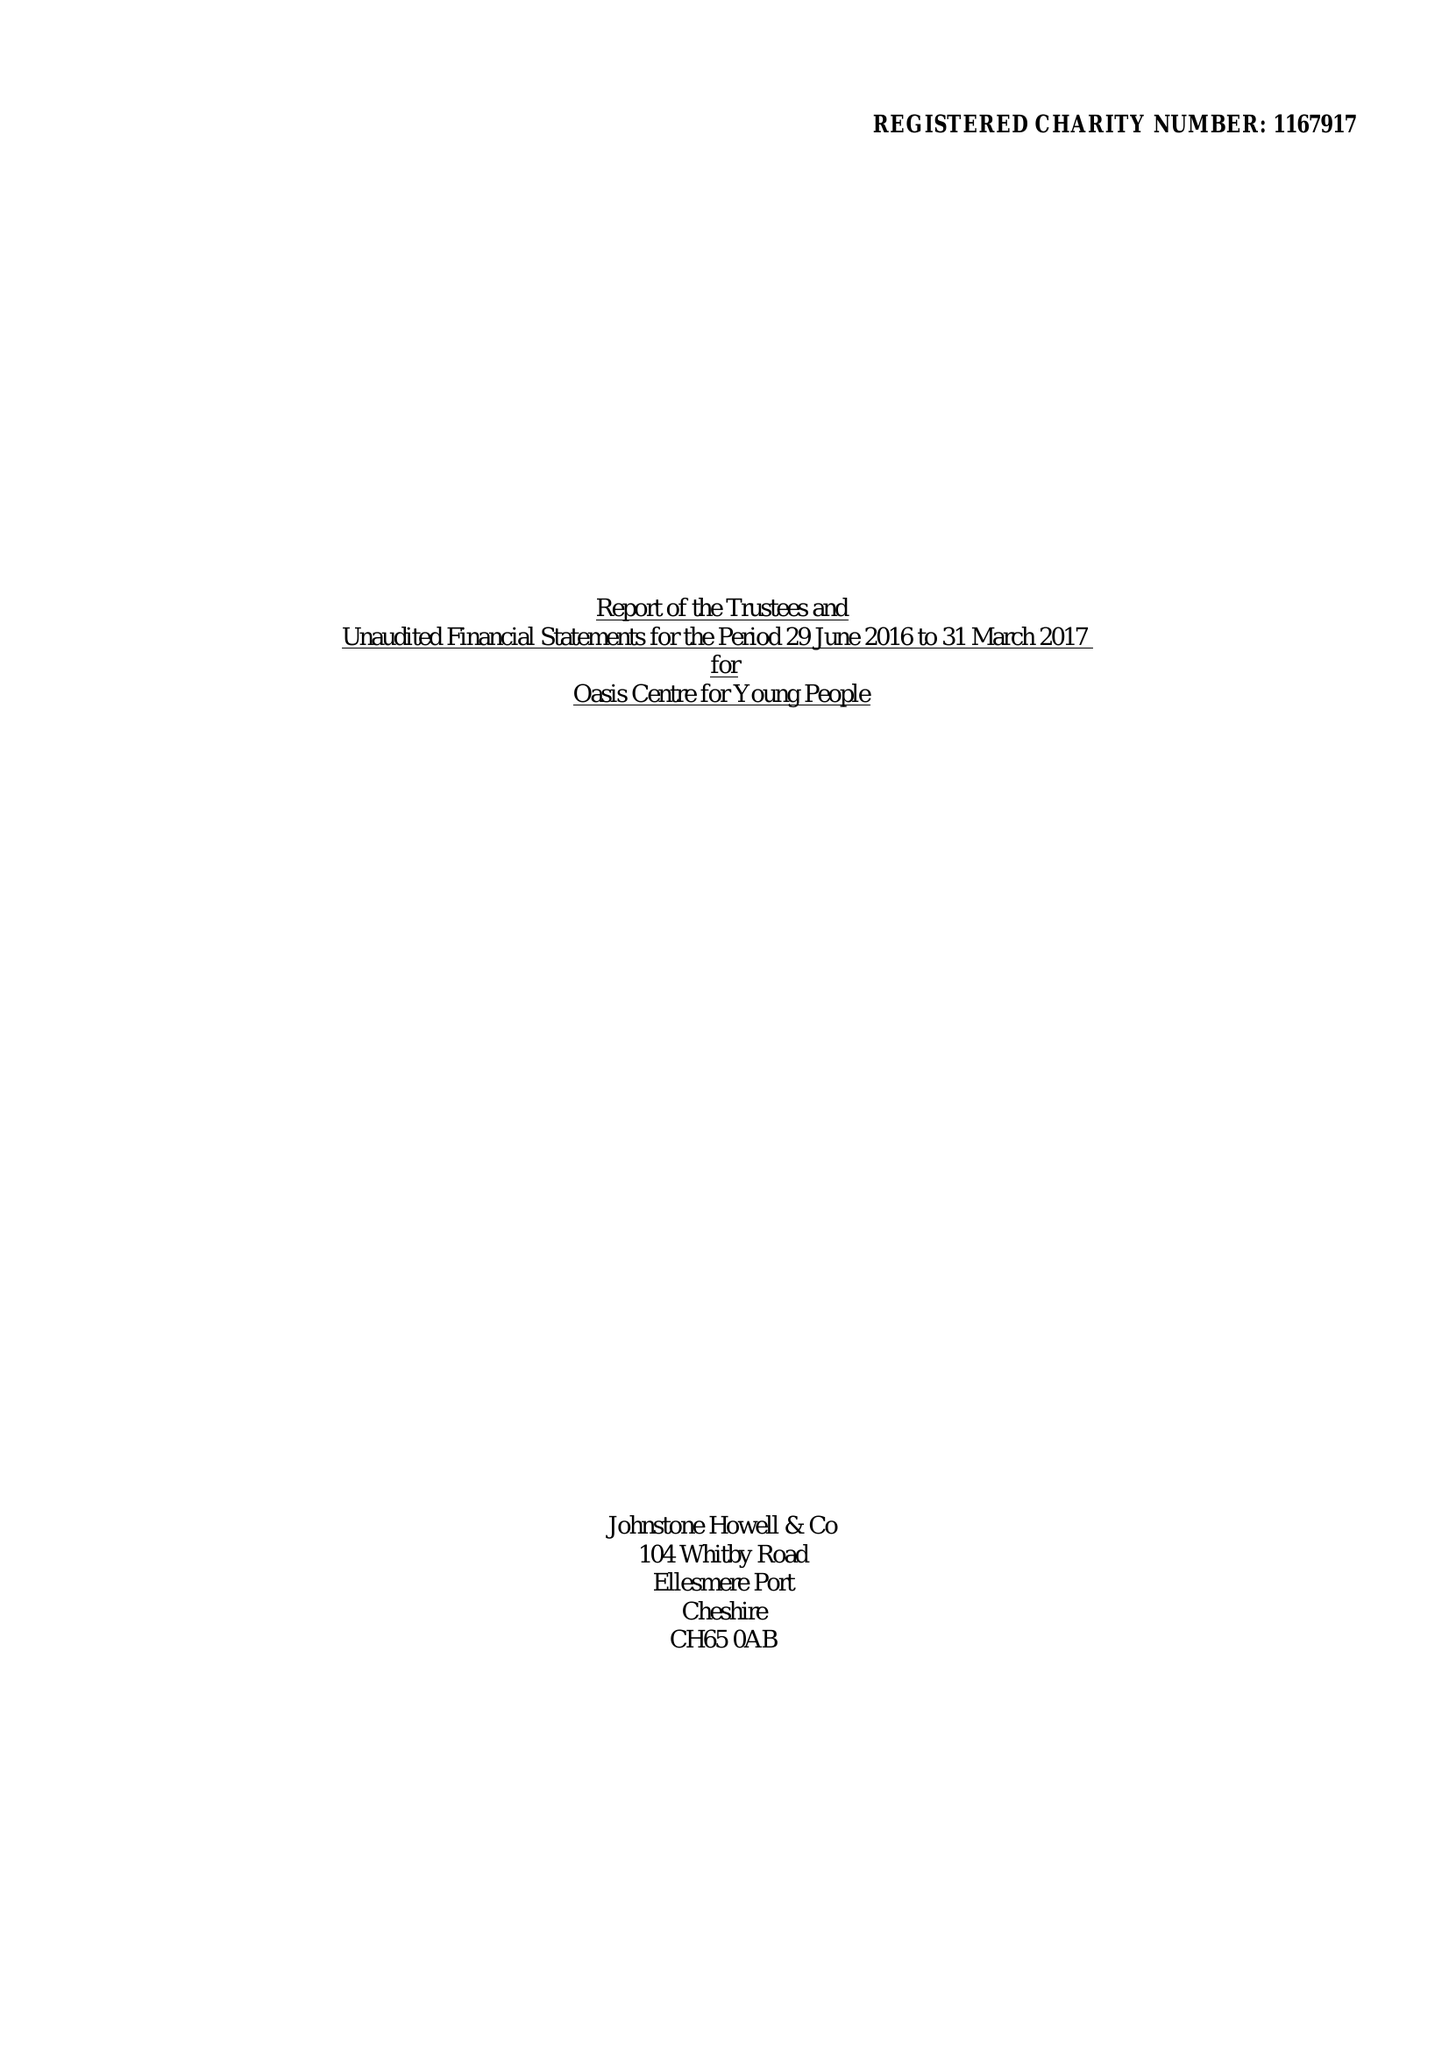What is the value for the income_annually_in_british_pounds?
Answer the question using a single word or phrase. 50067.00 